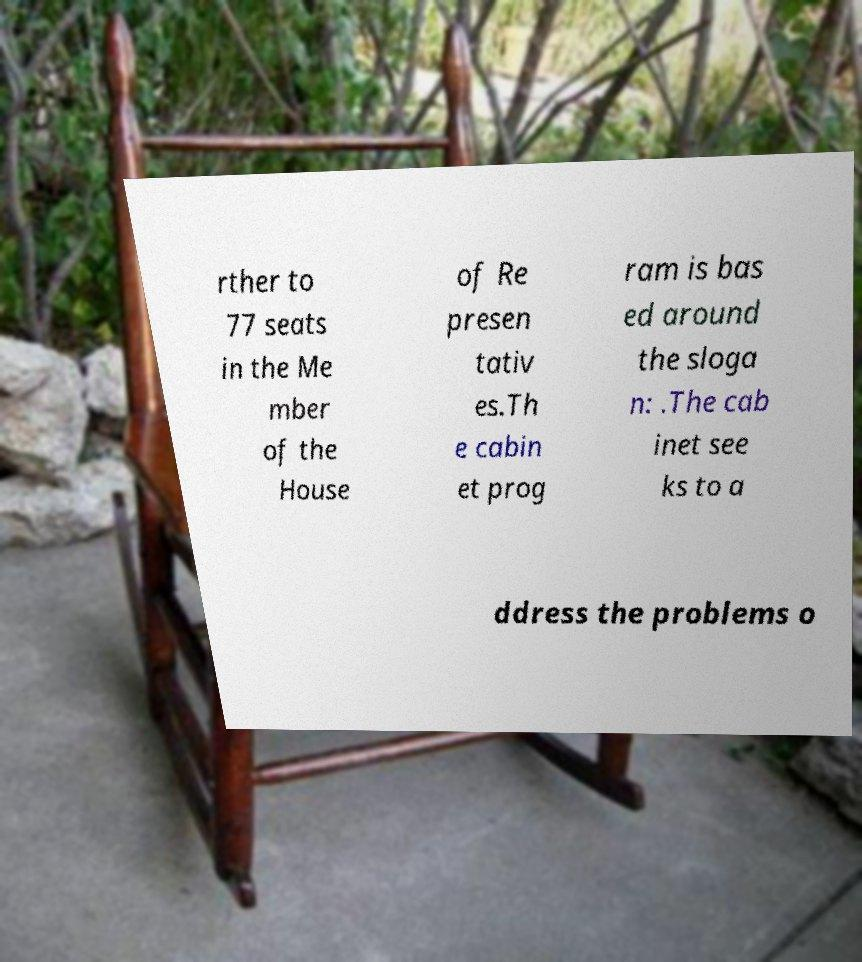Please read and relay the text visible in this image. What does it say? rther to 77 seats in the Me mber of the House of Re presen tativ es.Th e cabin et prog ram is bas ed around the sloga n: .The cab inet see ks to a ddress the problems o 